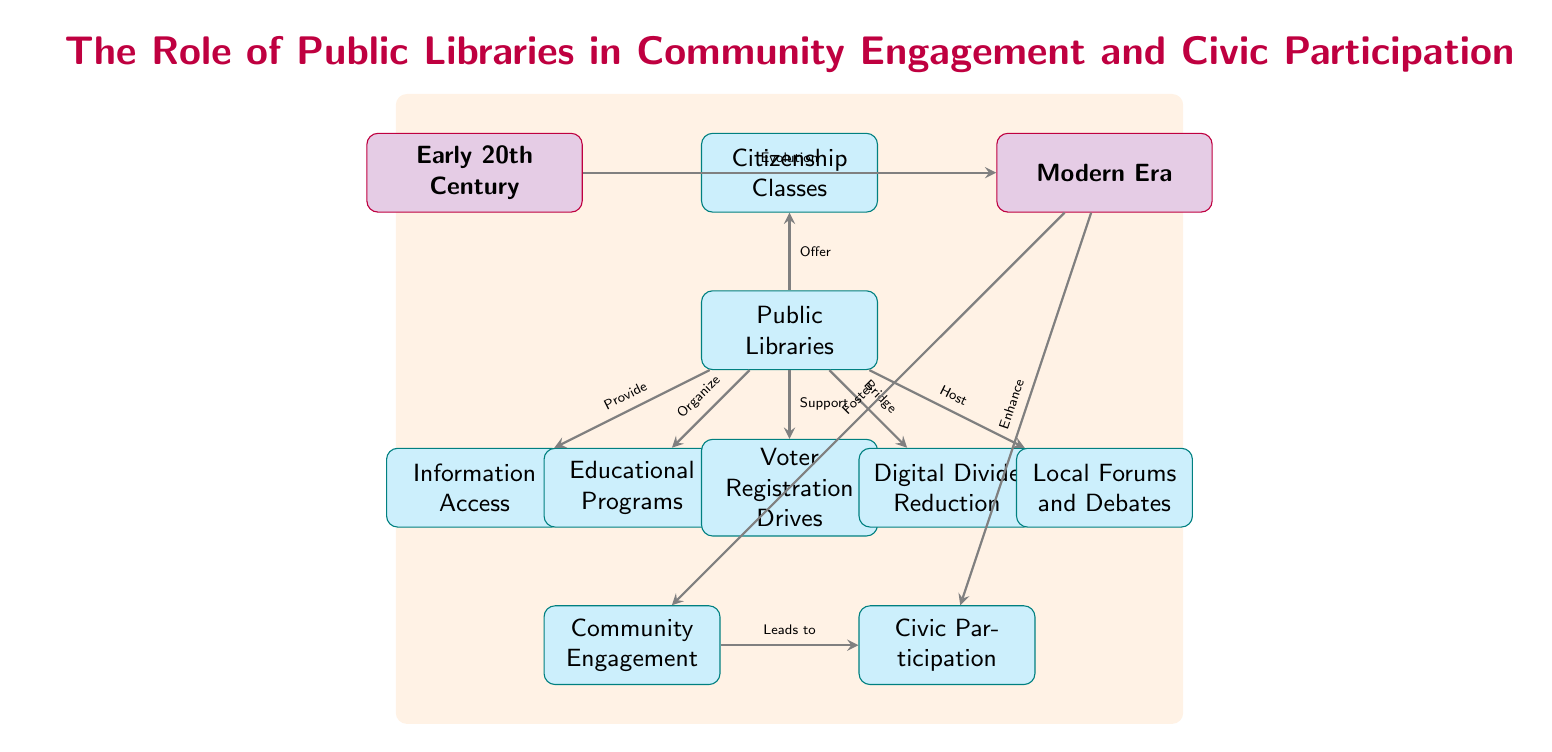What is the role of public libraries in community engagement? According to the diagram, public libraries organize community engagement efforts by providing information access and educational programs, which are direct contributions to local communities.
Answer: Organize What leads to civic participation according to the diagram? The diagram indicates that community engagement leads to civic participation, as shown by the edge connecting "Community Engagement" to "Civic Participation."
Answer: Community Engagement How many main nodes are there in the diagram? Upon inspecting the diagram, there are three main nodes representing key aspects related to public libraries: Community Engagement, Civic Participation, and Public Libraries.
Answer: Three Which node represents the historical aspect of the diagram? The timeline nodes are labeled "Early 20th Century" and "Modern Era," indicating that the historical element is represented by these timeline nodes.
Answer: Early 20th Century What is the connection between the modern era and civic participation? The diagram illustrates that the modern era enhances civic participation, as indicated by the edge connecting the "Modern Era" node with the "Civic Participation" node.
Answer: Enhance What type of programs do public libraries organize to support civic activities? The diagram shows that public libraries organize educational programs, which support various civic activities, including voter registration drives and local forums.
Answer: Educational Programs What role do public libraries have in addressing the digital divide? The diagram states that public libraries bridge the digital divide, demonstrating their commitment to making technology accessible to all members of the community.
Answer: Bridge Which node supports voter registration drives? The diagram clearly indicates that public libraries support voter registration drives, which is one of their specific contributions to civic participation efforts.
Answer: Support How does the timeline evolve from the early 20th century to the modern era? The diagram indicates the evolution from the early 20th century to the modern era through a direct link that signifies change and development in the role of public libraries over time.
Answer: Evolution 